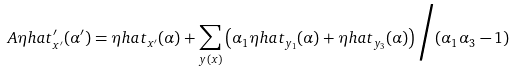<formula> <loc_0><loc_0><loc_500><loc_500>A \eta h a t _ { x ^ { \prime } } ^ { \prime } ( \alpha ^ { \prime } ) = \eta h a t _ { x ^ { \prime } } ( \alpha ) + \sum _ { y ( x ) } \left ( \alpha _ { 1 } \eta h a t _ { y _ { 1 } } ( \alpha ) + \eta h a t _ { y _ { 3 } } ( \alpha ) \right ) \Big / ( \alpha _ { 1 } \alpha _ { 3 } - 1 )</formula> 